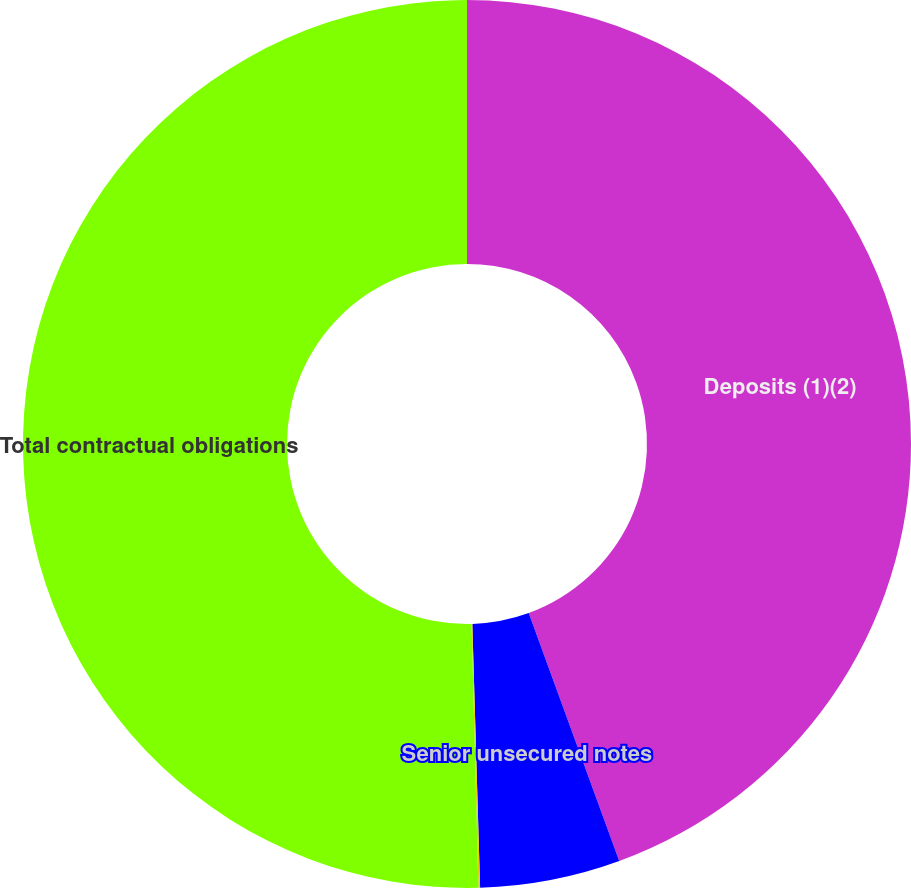Convert chart to OTSL. <chart><loc_0><loc_0><loc_500><loc_500><pie_chart><fcel>Deposits (1)(2)<fcel>Senior unsecured notes<fcel>Operating leases<fcel>Total contractual obligations<nl><fcel>44.43%<fcel>5.1%<fcel>0.06%<fcel>50.41%<nl></chart> 